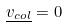Convert formula to latex. <formula><loc_0><loc_0><loc_500><loc_500>\underline { v _ { c o l } } = 0</formula> 